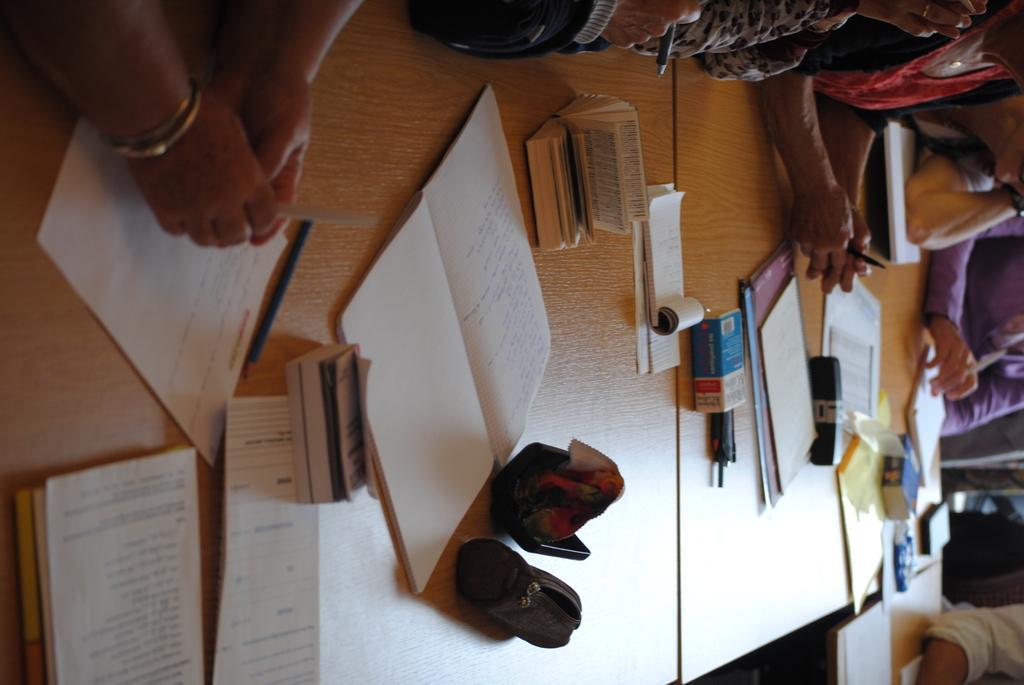Describe this image in one or two sentences. In this picture we can see a group of people and in front of them on tables we can see books, papers and boxes. 